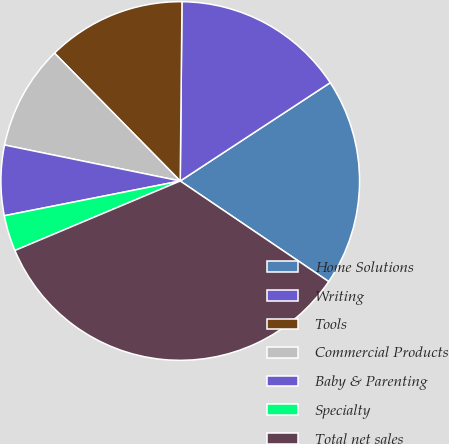Convert chart. <chart><loc_0><loc_0><loc_500><loc_500><pie_chart><fcel>Home Solutions<fcel>Writing<fcel>Tools<fcel>Commercial Products<fcel>Baby & Parenting<fcel>Specialty<fcel>Total net sales<nl><fcel>18.71%<fcel>15.61%<fcel>12.52%<fcel>9.42%<fcel>6.32%<fcel>3.23%<fcel>34.19%<nl></chart> 